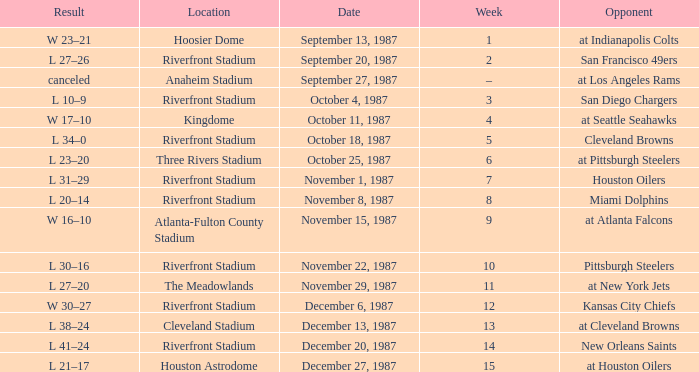What was the result of the game at the Riverfront Stadium after week 8? L 20–14. 